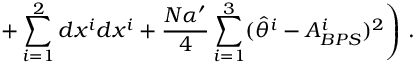<formula> <loc_0><loc_0><loc_500><loc_500>+ \sum _ { i = 1 } ^ { 2 } d x ^ { i } d x ^ { i } + \frac { N \alpha ^ { \prime } } { 4 } \sum _ { i = 1 } ^ { 3 } ( \hat { \theta } ^ { i } - A _ { B P S } ^ { i } ) ^ { 2 } \right ) \, .</formula> 